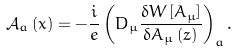<formula> <loc_0><loc_0><loc_500><loc_500>\mathcal { A } _ { a } \left ( x \right ) = - \frac { i } { e } \left ( D _ { \mu } \frac { \delta W \left [ A _ { \mu } \right ] } { \delta A _ { \mu } \left ( z \right ) } \right ) _ { a } .</formula> 